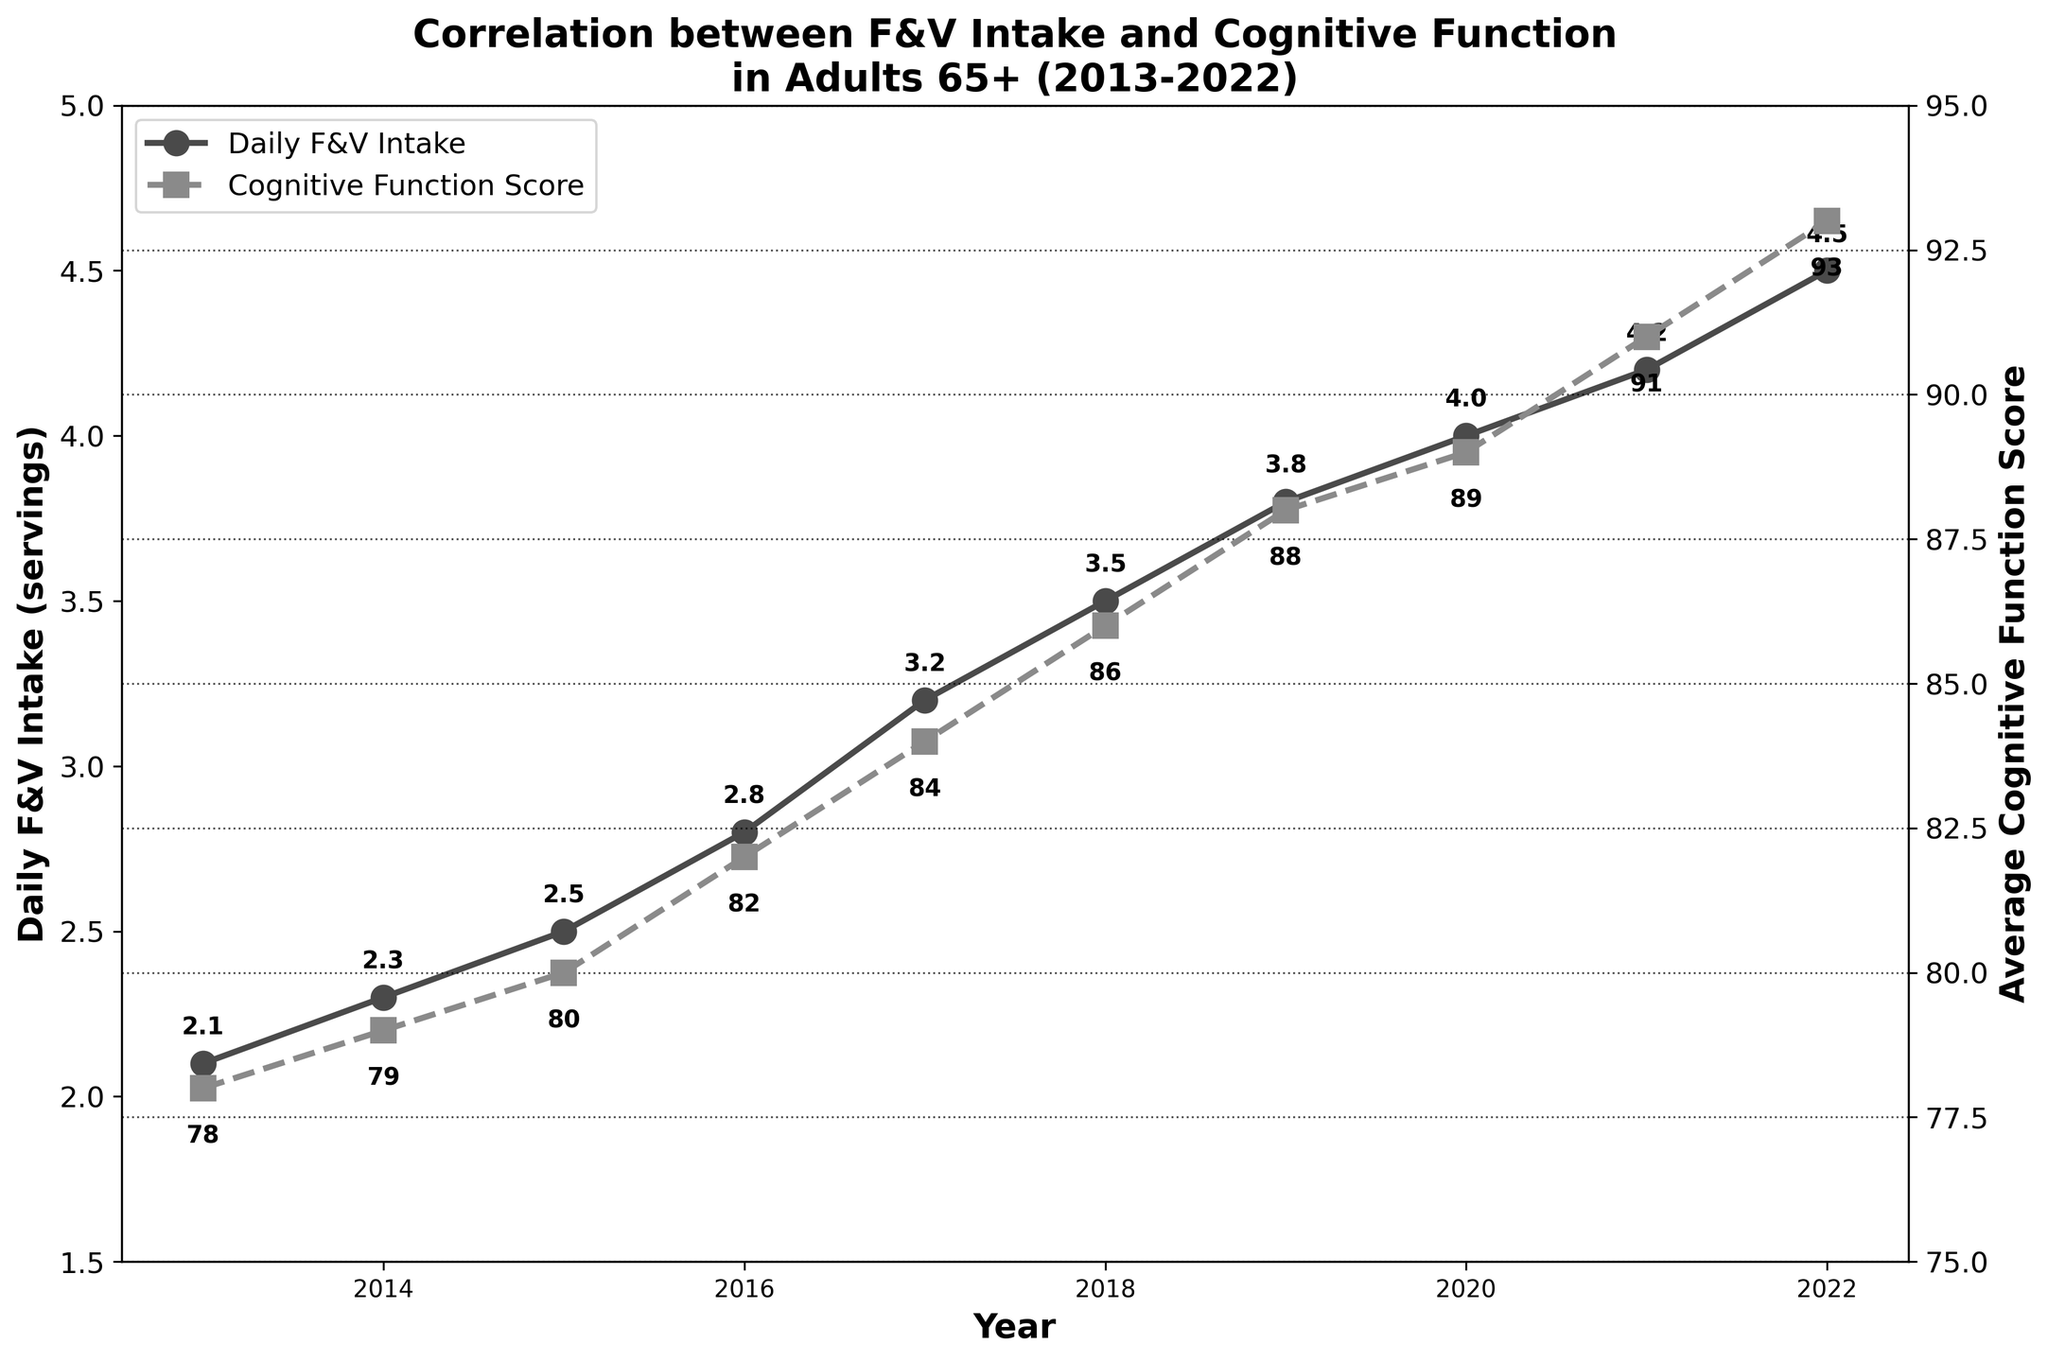What is the highest Daily F&V Intake recorded in the data? The highest Daily F&V Intake can be found by looking for the peak value on the "Daily F&V Intake (servings)" line. The line reaches its maximum at 4.5 servings in 2022.
Answer: 4.5 servings In which year did the Cognitive Function Score cross 90 for the first time? To find this, observe the "Average Cognitive Function Score" line, and identify the first point where it exceeds 90. This happens in 2021 when the score is 91.
Answer: 2021 How much did the Daily F&V Intake increase from 2013 to 2022? Find the Daily F&V Intake values for 2013 and 2022, then subtract the earlier value from the later one. In 2013, it was 2.1 servings, and in 2022, it was 4.5 servings, so the increase is 4.5 - 2.1 = 2.4 servings.
Answer: 2.4 servings Which year had the smallest increase in Cognitive Function Score compared to the previous year? To determine this, look for the year-to-year differences in Cognitive Function Scores and identify the smallest positive change. The increase from 2020 to 2021 is the smallest, with a change from 89 to 91, a difference of 2 points.
Answer: 2021 What was the average Cognitive Function Score across the entire period? Calculate the average by summing all Cognitive Function Scores and dividing by the number of years. The sum is 78 + 79 + 80 + 82 + 84 + 86 + 88 + 89 + 91 + 93 = 850, and the average is 850/10 = 85.
Answer: 85 By how many servings did the Daily F&V Intake increase from 2016 to 2017? To find this, subtract the Daily F&V Intake for 2016 from that of 2017. The intake was 2.8 servings in 2016 and 3.2 servings in 2017, so the increase is 3.2 - 2.8 = 0.4 servings.
Answer: 0.4 servings Compare the rates of increase in Daily F&V Intake and Cognitive Function Score between 2019 and 2020. Which one increased more, and by how much? First, find the differences for both metrics between 2019 and 2020. The Daily F&V Intake increased from 3.8 to 4.0 servings (0.2 servings), and the Cognitive Function Score increased from 88 to 89 (1 point). The Cognitive Function Score had a greater increase by 0.8 (1 - 0.2).
Answer: Cognitive Function Score, by 0.8 What is the slope of the Daily F&V Intake line between 2018 and 2020? The slope is determined by the change in Daily F&V Intake divided by the change in years. From 2018 (3.5 servings) to 2020 (4.0 servings), the change is 4.0 - 3.5 = 0.5 servings over 2 years, so the slope is 0.5/2 = 0.25 servings per year.
Answer: 0.25 servings per year 